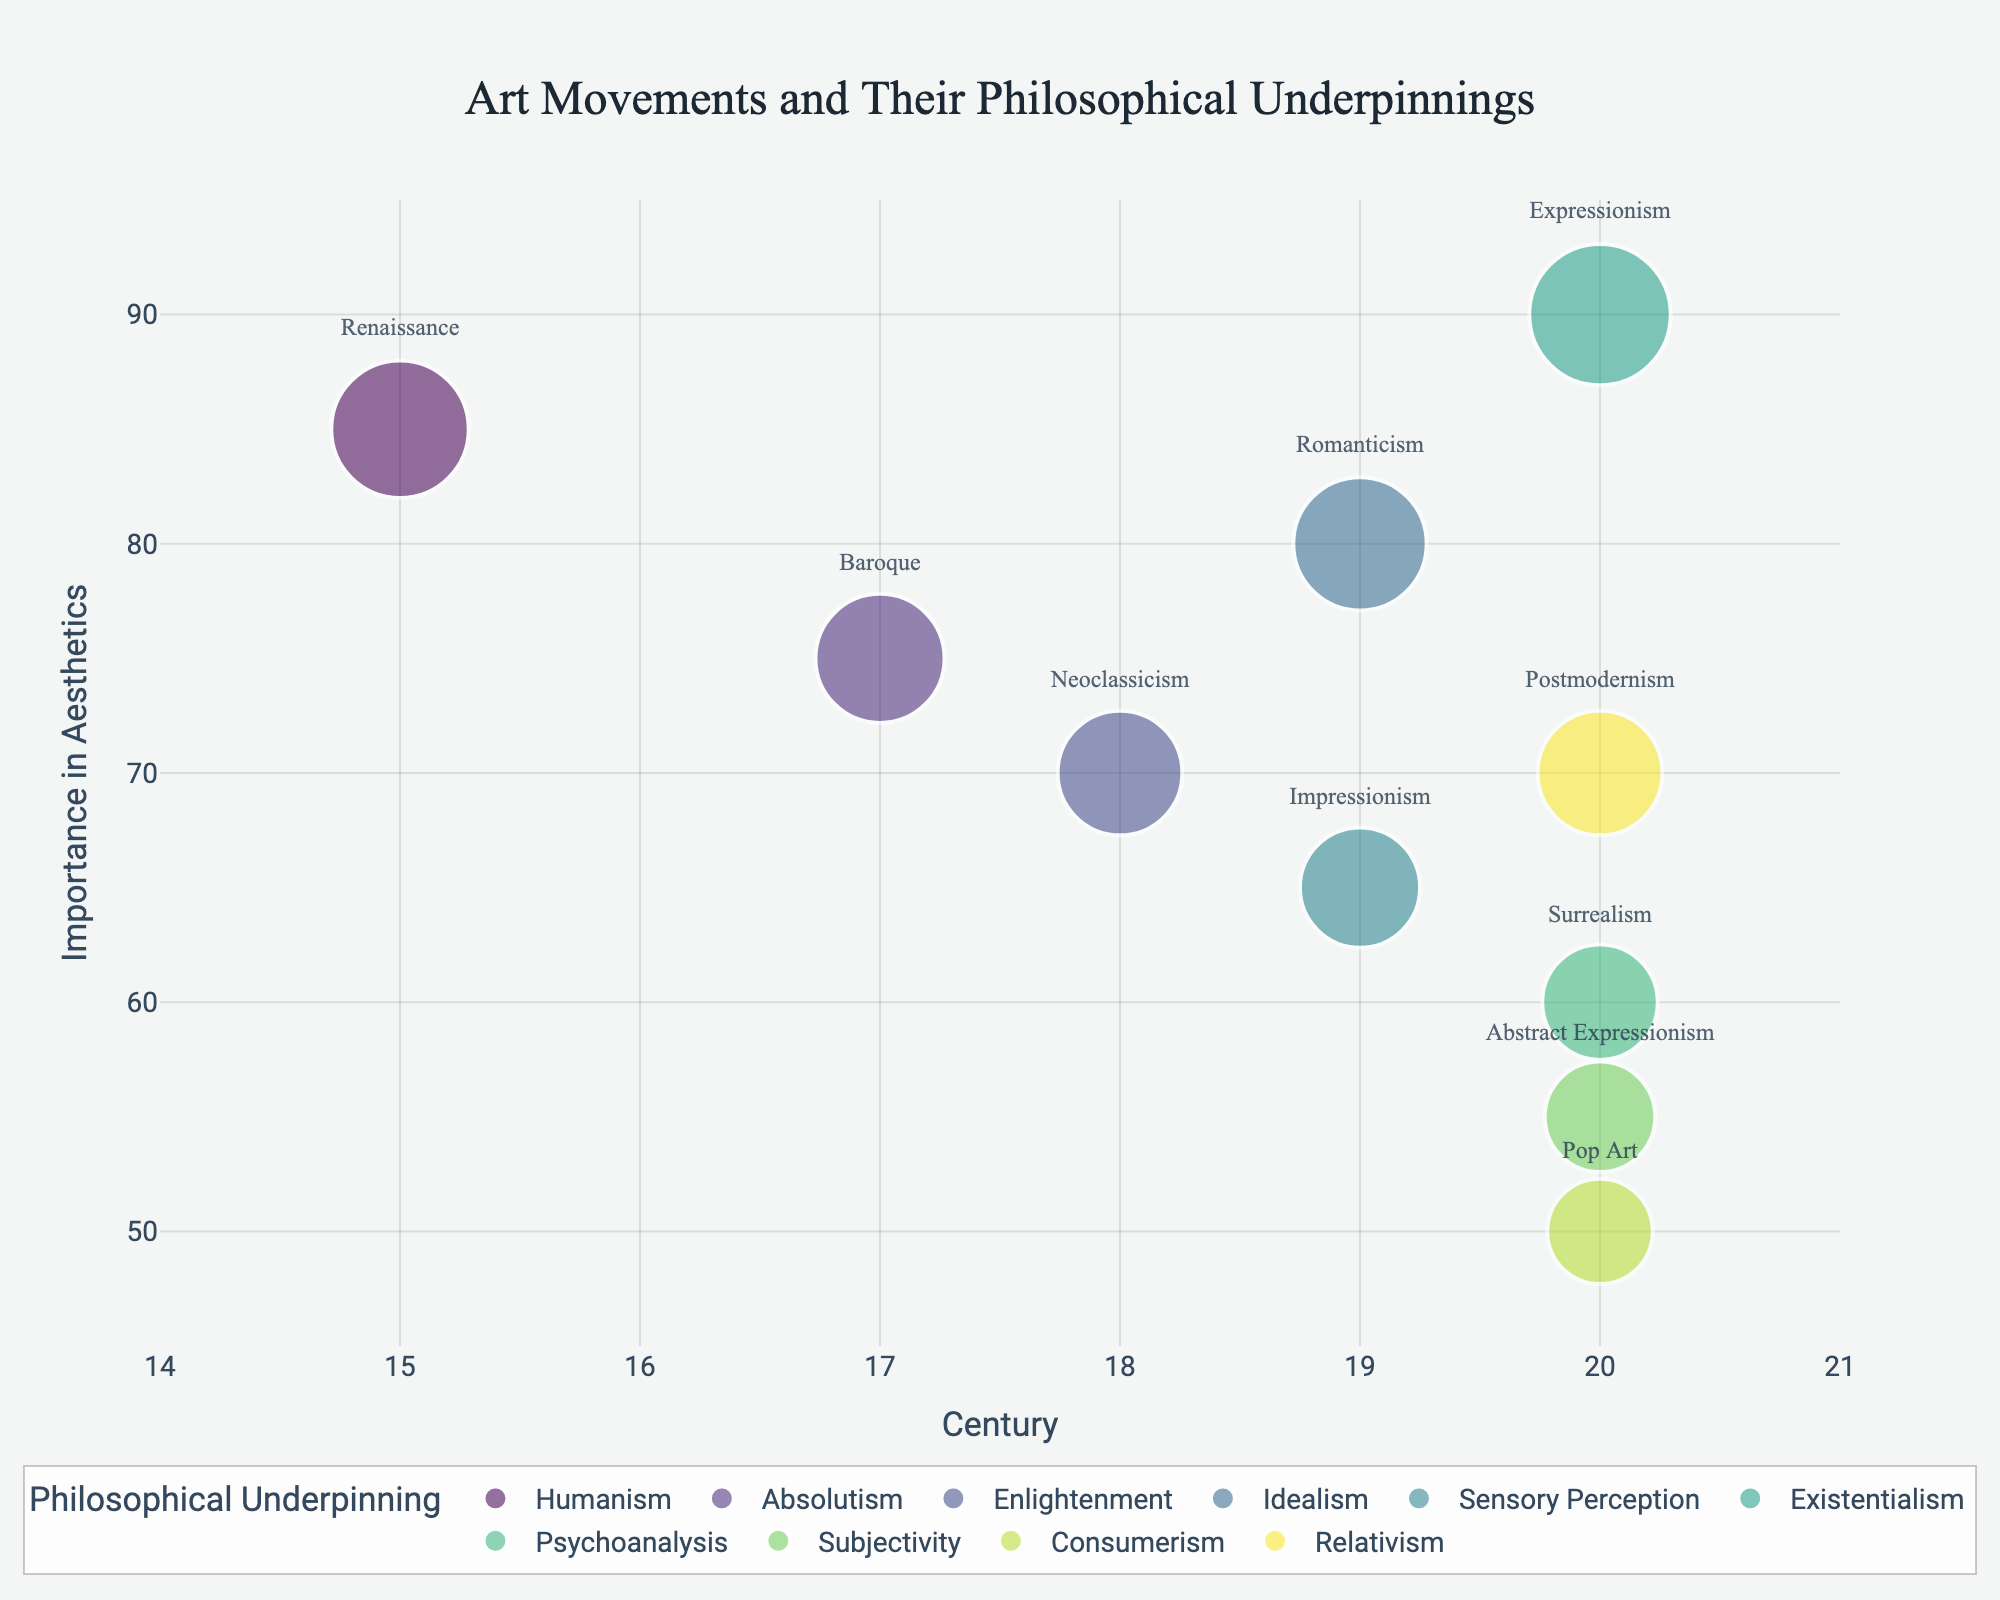What is the title of the figure? The title is located at the top of the figure, centered and prominently displayed in a larger font.
Answer: Art Movements and Their Philosophical Underpinnings Which art movement is most closely associated with existentialism and in which century is it placed on the chart? By finding the bubble labeled "Existentialism" in the legend and matching it with its respective bubble in the chart, you can see that the "Expressionism" movement aligns with it. The bubble for "Expressionism" is placed in the 20th century on the x-axis.
Answer: Expressionism, 20th century How many unique philosophical underpinnings are displayed in the chart? Count the distinct categories provided in the color legend of the chart, each representing a unique philosophical underpinning. There are 9 unique categories listed.
Answer: 9 What is the art movement with the highest importance in aesthetics according to the chart? Look for the bubble with the largest size and highest y-axis value, which is labeled "Importance." The largest bubble, indicating the highest importance, corresponds to "Expressionism."
Answer: Expressionism Which two art movements share the same century but have different philosophical underpinnings and levels of importance on the chart? Look for multiple bubbles aligned vertically within the same century on the x-axis. "Romanticism" and "Impressionism" are both located in the 19th century but differ in philosophical underpinnings ("Idealism" and "Sensory Perception" respectively) and importance (80 and 65 respectively).
Answer: Romanticism and Impressionism How does the importance of Baroque compare to that of Neoclassicism on the chart? Find the two bubbles corresponding to "Baroque" and "Neoclassicism." Compare their y-axis positions labeled "Importance." The Baroque bubble is at 75, while Neoclassicism is at 70, indicating Baroque's importance is slightly higher than Neoclassicism's.
Answer: Baroque’s importance is higher than Neoclassicism’s What range of centuries is represented on the x-axis of the chart? Examine the x-axis labels which represent centuries, ranging from the earliest to the latest. The chart includes centuries from the 15th to the 21st century.
Answer: 15th to 21st century Which art movement is associated with consumerism and what is its importance according to the chart? Locate the bubble linked to "Consumerism" in the legend and chart, matching it with its respective art movement. "Pop Art" aligns with consumerism and has an importance value of 50.
Answer: Pop Art, 50 What is the importance value of Surrealism, and how does it compare to Impressionism? Find "Surrealism" and "Impressionism" on the chart. Surrealism has an importance value of 60, while Impressionism stands at 65. Impressionism has a higher importance value than Surrealism by 5 points.
Answer: Surrealism is 60; Impressionism is higher by 5 points 